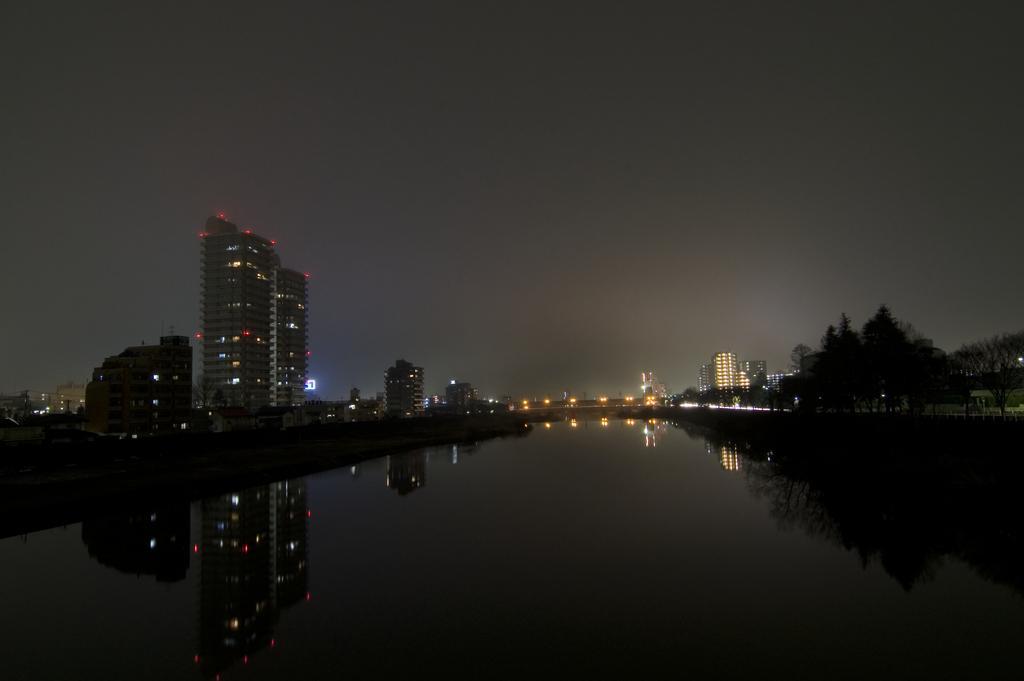How would you summarize this image in a sentence or two? This picture is taken from outside of the city. In this image, on the right side, we can see some trees, plants, buildings. In the middle of the image, we can see water in a lake. On the left side, we can also see some buildings, tower, trees. In the background, we can see some lights, buildings. At the top, we can see a sky which is in black color, at the bottom, we can also see water is also in black color. 